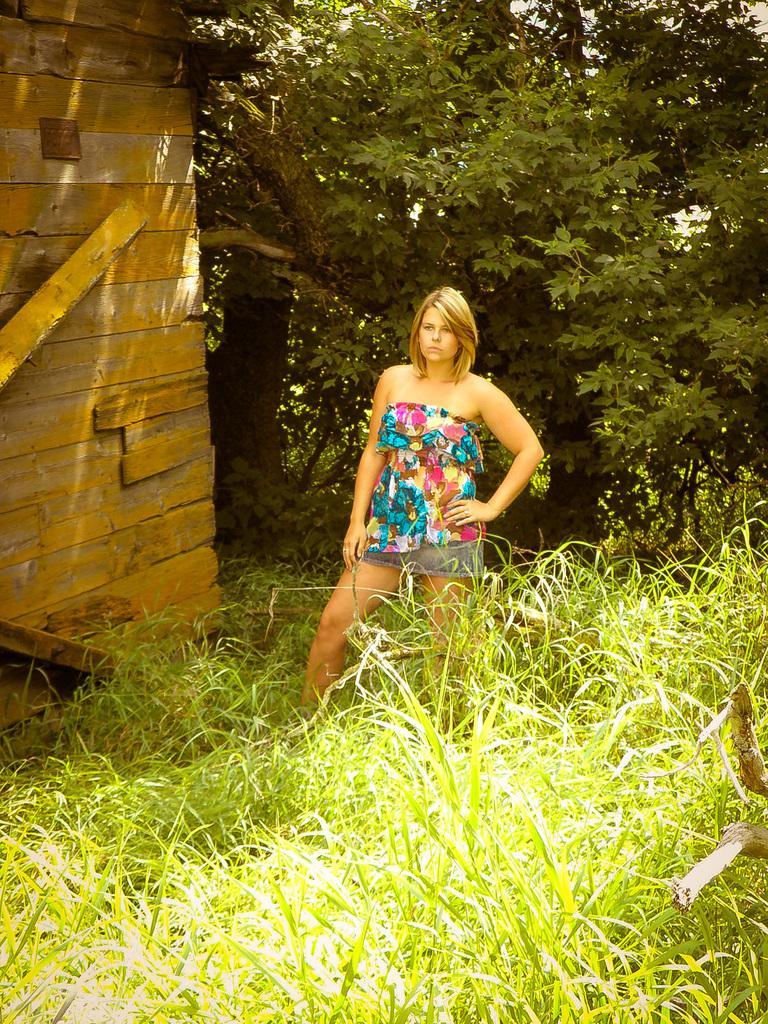In one or two sentences, can you explain what this image depicts? In this image we can see a woman standing on the ground. Here we can see grass and wall. In the background there are trees. 